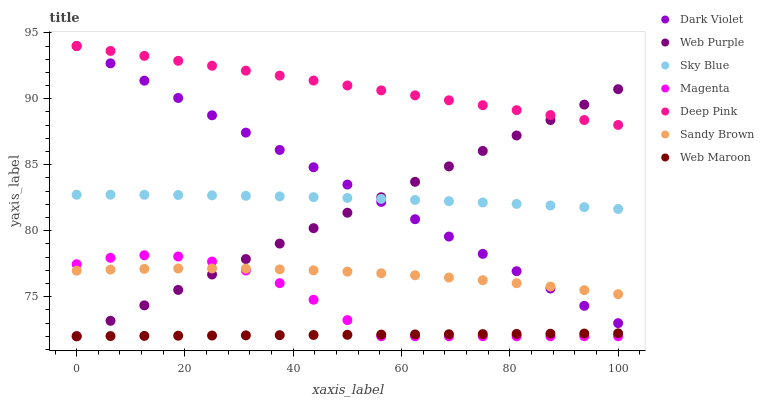Does Web Maroon have the minimum area under the curve?
Answer yes or no. Yes. Does Deep Pink have the maximum area under the curve?
Answer yes or no. Yes. Does Dark Violet have the minimum area under the curve?
Answer yes or no. No. Does Dark Violet have the maximum area under the curve?
Answer yes or no. No. Is Dark Violet the smoothest?
Answer yes or no. Yes. Is Magenta the roughest?
Answer yes or no. Yes. Is Web Maroon the smoothest?
Answer yes or no. No. Is Web Maroon the roughest?
Answer yes or no. No. Does Web Maroon have the lowest value?
Answer yes or no. Yes. Does Dark Violet have the lowest value?
Answer yes or no. No. Does Dark Violet have the highest value?
Answer yes or no. Yes. Does Web Maroon have the highest value?
Answer yes or no. No. Is Sky Blue less than Deep Pink?
Answer yes or no. Yes. Is Deep Pink greater than Sky Blue?
Answer yes or no. Yes. Does Dark Violet intersect Web Purple?
Answer yes or no. Yes. Is Dark Violet less than Web Purple?
Answer yes or no. No. Is Dark Violet greater than Web Purple?
Answer yes or no. No. Does Sky Blue intersect Deep Pink?
Answer yes or no. No. 